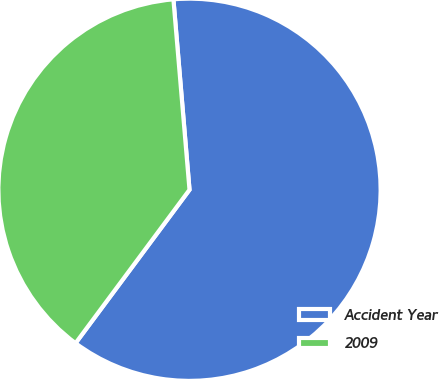<chart> <loc_0><loc_0><loc_500><loc_500><pie_chart><fcel>Accident Year<fcel>2009<nl><fcel>61.51%<fcel>38.49%<nl></chart> 